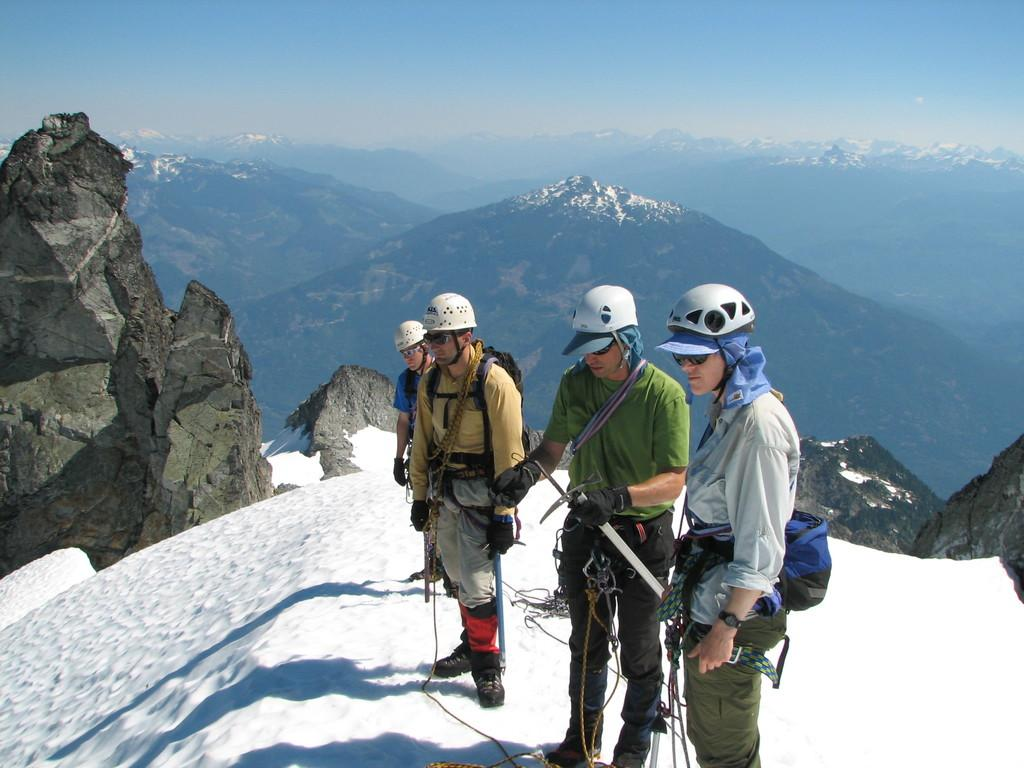Who or what is present in the image? There are people in the image. What are the people wearing on their heads? The people are wearing helmets. Where are the people standing? The people are standing on a hill. What is at the bottom of the hill? There is snow at the bottom of the hill. What can be seen in the distance behind the hill? There are mountains in the background of the image. What is visible at the top of the image? The sky is visible at the top of the image. Are there any bears visible in the image? No, there are no bears present in the image. What type of zephyr can be seen blowing through the mountains in the image? There is no mention of a zephyr or any wind in the image; it only shows people standing on a hill with mountains in the background. 